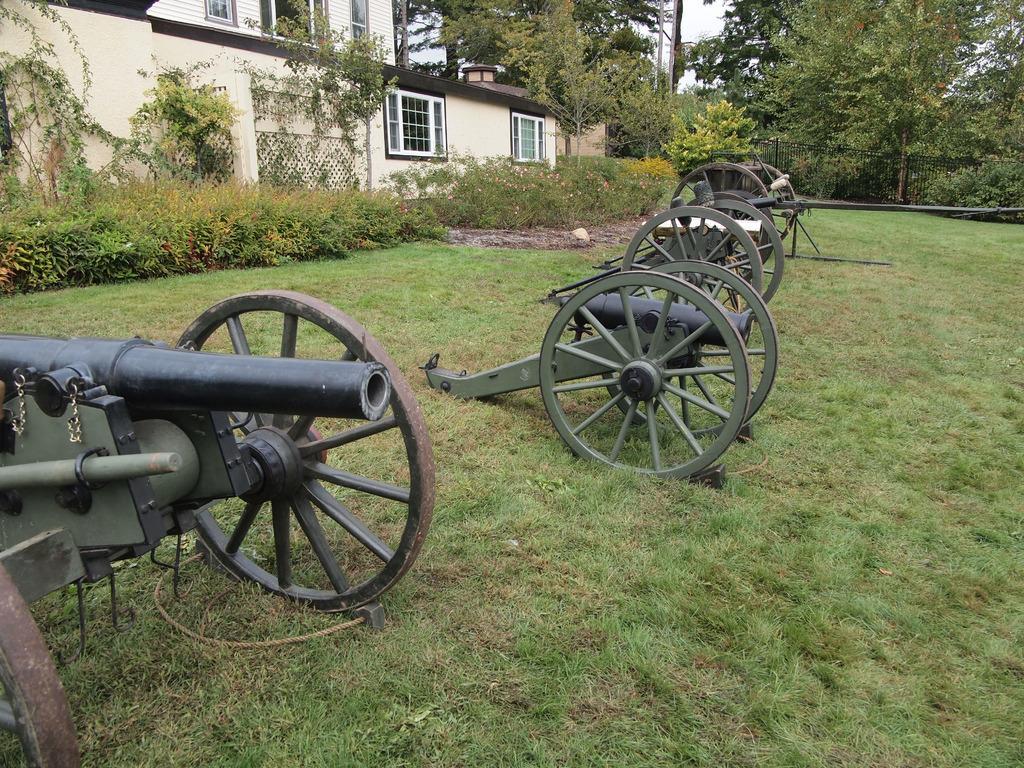In one or two sentences, can you explain what this image depicts? In this image in the center there are some vehicles and at the bottom there is grass, in the background there is a fence house, trees, plants. In the center there is pole. 